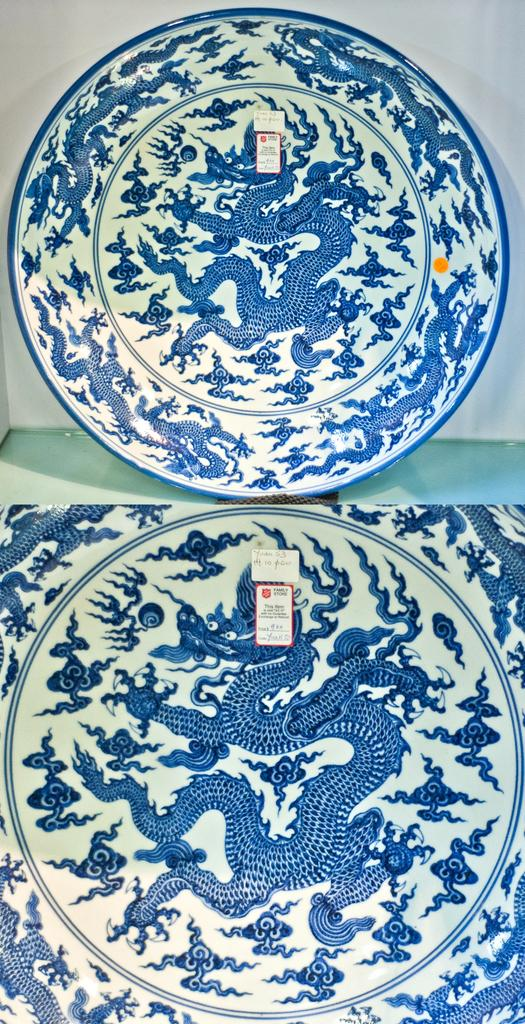What type of artwork is shown in the image? The image is a collage. What can be seen on the platform in the image? There is a plate on a platform in the image. What is on the plate? The plate has stickers on it. What can be seen in the background of the image? There is a wall visible in the background of the image. How does the honey affect the kiss in the image? There is no honey or kiss present in the image. What type of punishment is being given to the person in the image? There is no person or punishment depicted in the image. 